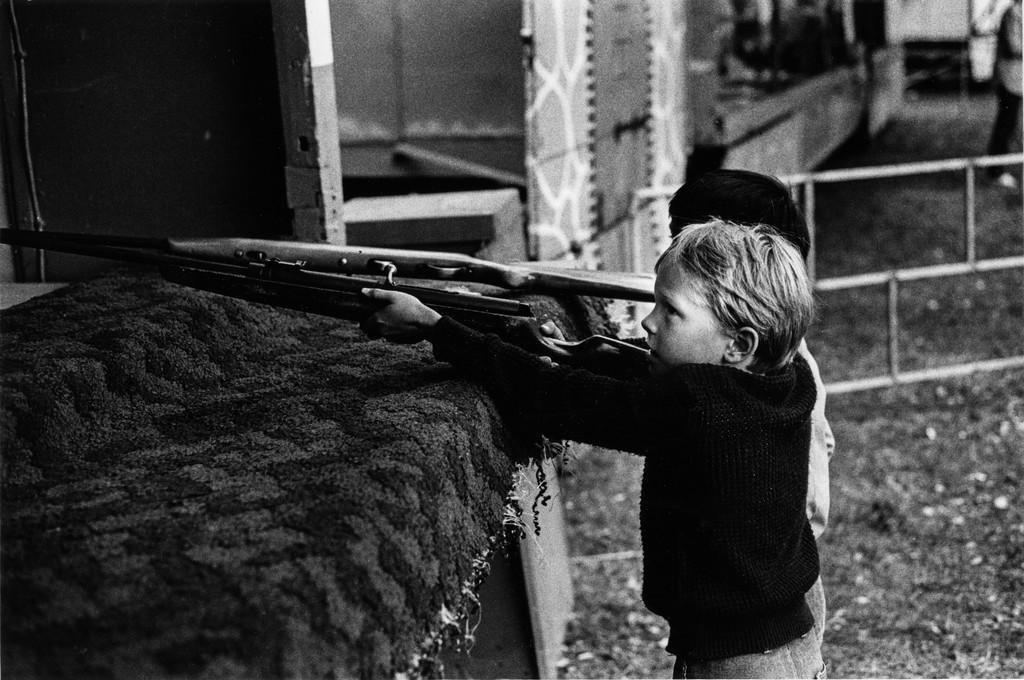Can you describe this image briefly? This is a black and white image where we can see two children are holding weapons in the hands and standing on the ground. Here we can see the table. The background of the image is slightly blurred, where we can see the fence. 